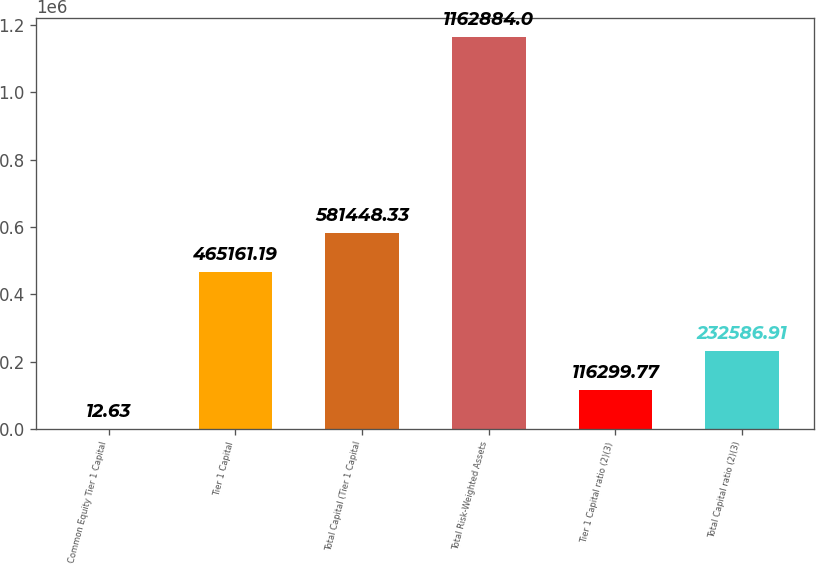Convert chart. <chart><loc_0><loc_0><loc_500><loc_500><bar_chart><fcel>Common Equity Tier 1 Capital<fcel>Tier 1 Capital<fcel>Total Capital (Tier 1 Capital<fcel>Total Risk-Weighted Assets<fcel>Tier 1 Capital ratio (2)(3)<fcel>Total Capital ratio (2)(3)<nl><fcel>12.63<fcel>465161<fcel>581448<fcel>1.16288e+06<fcel>116300<fcel>232587<nl></chart> 